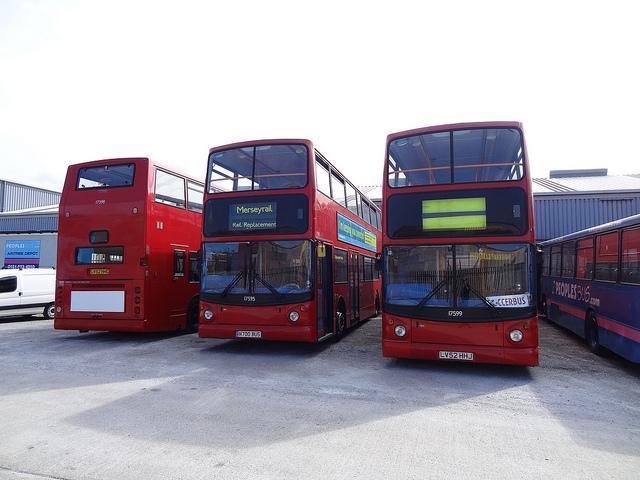How many levels these buses have?
Give a very brief answer. 2. How many buses are there?
Give a very brief answer. 4. How many people are wearing shorts?
Give a very brief answer. 0. 